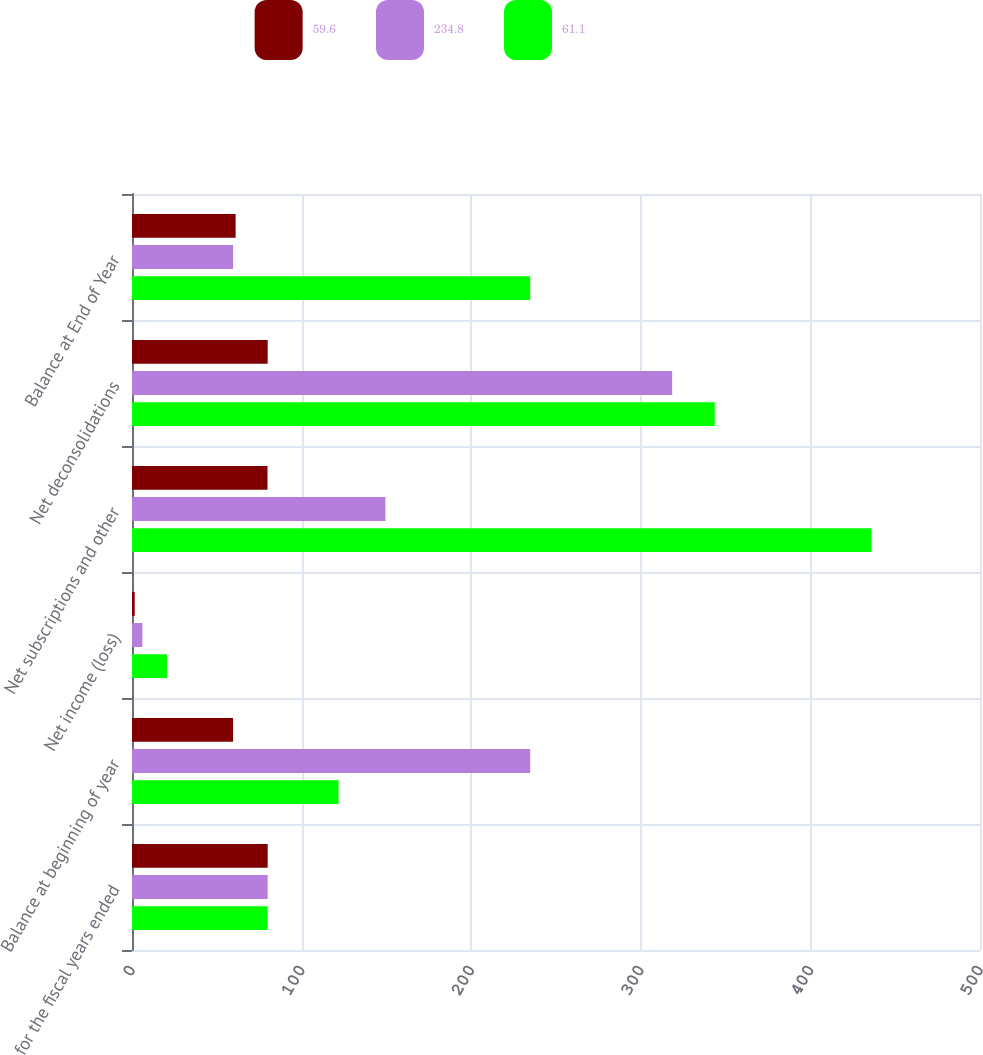Convert chart. <chart><loc_0><loc_0><loc_500><loc_500><stacked_bar_chart><ecel><fcel>for the fiscal years ended<fcel>Balance at beginning of year<fcel>Net income (loss)<fcel>Net subscriptions and other<fcel>Net deconsolidations<fcel>Balance at End of Year<nl><fcel>59.6<fcel>80<fcel>59.6<fcel>1.6<fcel>79.9<fcel>80<fcel>61.1<nl><fcel>234.8<fcel>80<fcel>234.8<fcel>6.1<fcel>149.4<fcel>318.5<fcel>59.6<nl><fcel>61.1<fcel>80<fcel>121.8<fcel>20.6<fcel>436<fcel>343.6<fcel>234.8<nl></chart> 